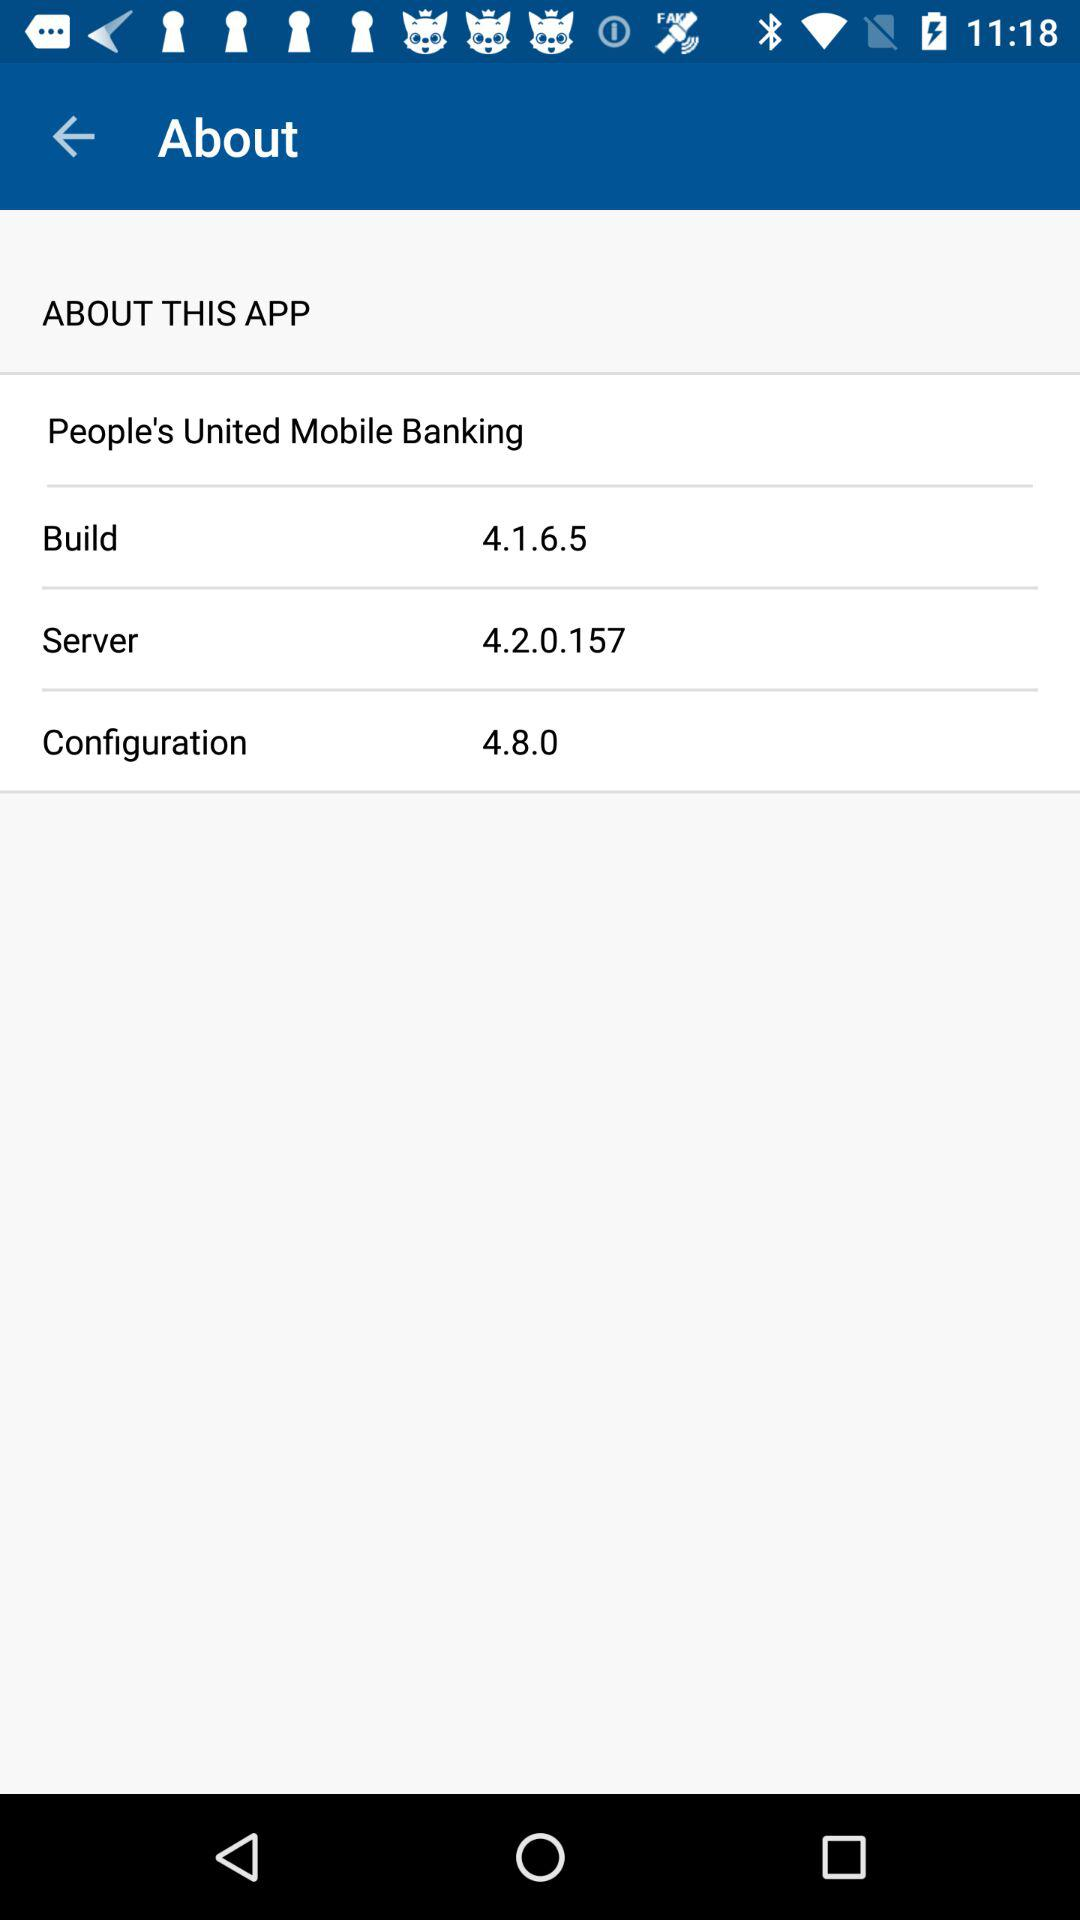What is the server? The server is 4.2.0.157. 